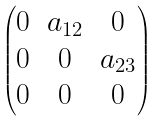<formula> <loc_0><loc_0><loc_500><loc_500>\begin{pmatrix} 0 & a _ { 1 2 } & 0 \\ 0 & 0 & a _ { 2 3 } \\ 0 & 0 & 0 \\ \end{pmatrix}</formula> 